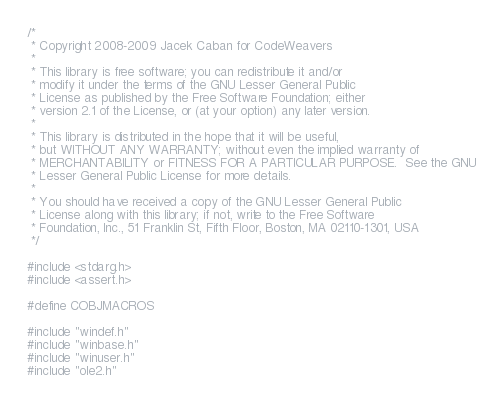<code> <loc_0><loc_0><loc_500><loc_500><_C_>/*
 * Copyright 2008-2009 Jacek Caban for CodeWeavers
 *
 * This library is free software; you can redistribute it and/or
 * modify it under the terms of the GNU Lesser General Public
 * License as published by the Free Software Foundation; either
 * version 2.1 of the License, or (at your option) any later version.
 *
 * This library is distributed in the hope that it will be useful,
 * but WITHOUT ANY WARRANTY; without even the implied warranty of
 * MERCHANTABILITY or FITNESS FOR A PARTICULAR PURPOSE.  See the GNU
 * Lesser General Public License for more details.
 *
 * You should have received a copy of the GNU Lesser General Public
 * License along with this library; if not, write to the Free Software
 * Foundation, Inc., 51 Franklin St, Fifth Floor, Boston, MA 02110-1301, USA
 */

#include <stdarg.h>
#include <assert.h>

#define COBJMACROS

#include "windef.h"
#include "winbase.h"
#include "winuser.h"
#include "ole2.h"</code> 